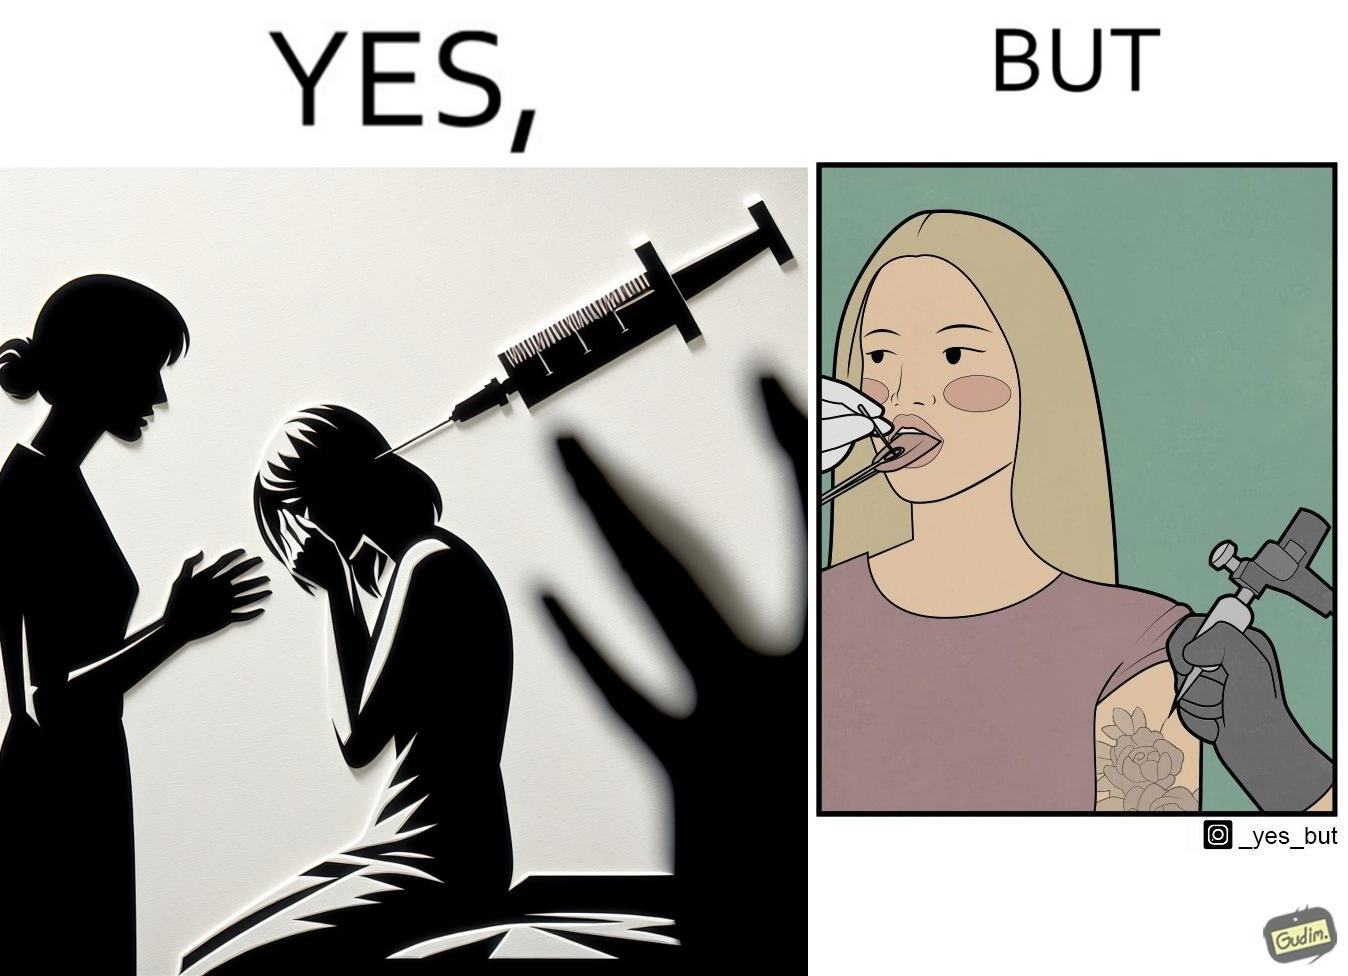What is shown in the left half versus the right half of this image? In the left part of the image: The iamge shows a woman scared of the syringe about to be used to inject her with medicine. In the right part of the image: The image shows a woman with her tongue out getting a piercing in her tongue. The image also shows shows the same woman getting tattoed on her left arm at the same time as getting  a piercing. 